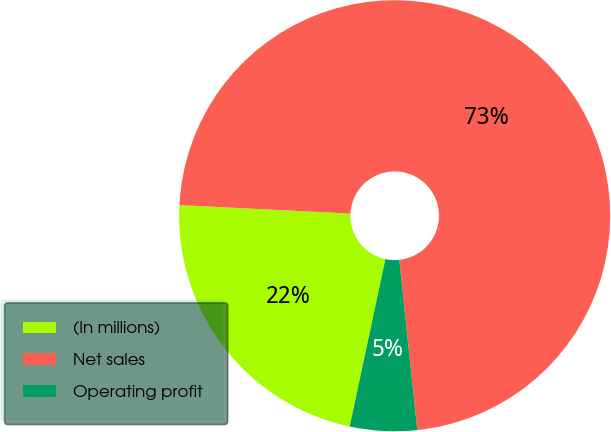Convert chart. <chart><loc_0><loc_0><loc_500><loc_500><pie_chart><fcel>(In millions)<fcel>Net sales<fcel>Operating profit<nl><fcel>22.44%<fcel>72.54%<fcel>5.02%<nl></chart> 